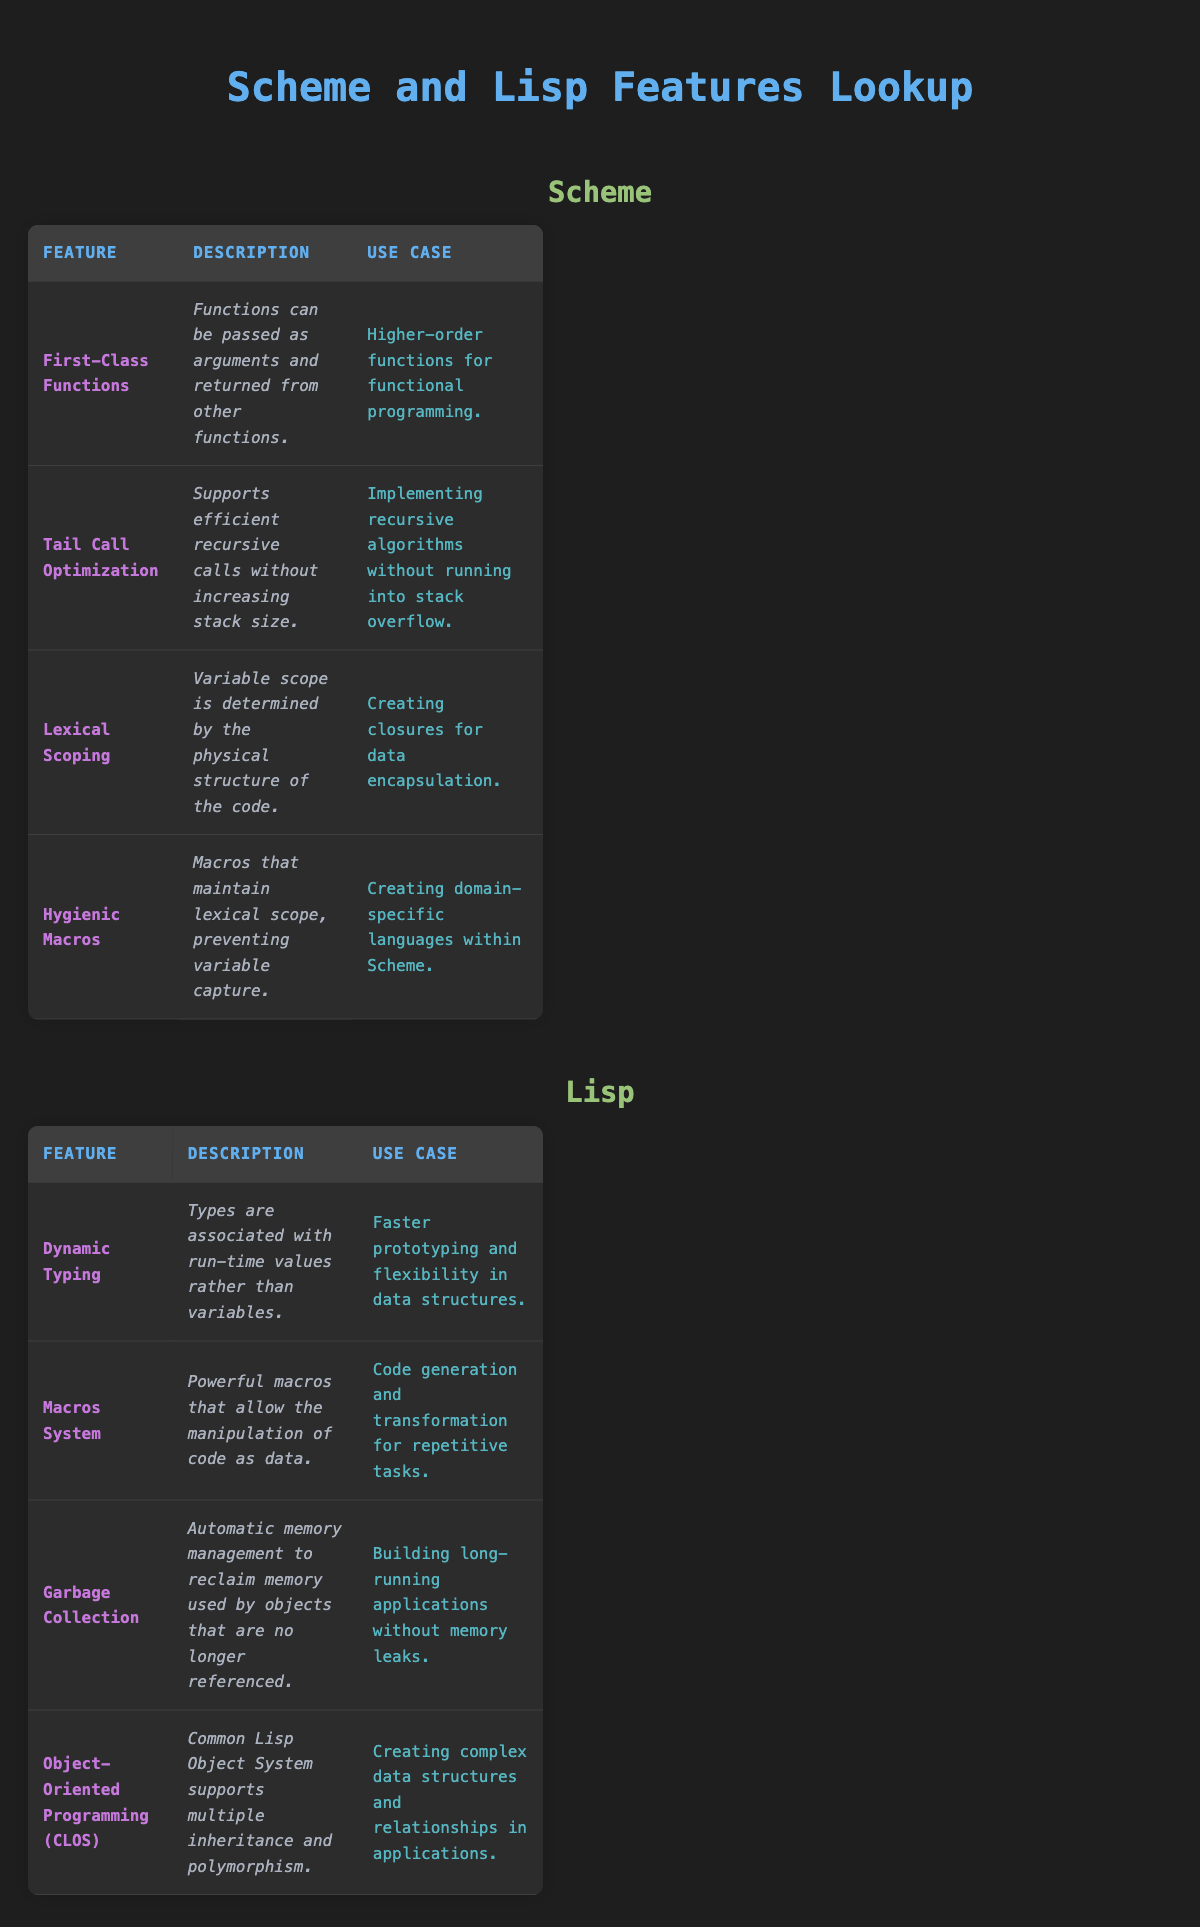What's a feature of Scheme that supports higher-order functions? According to the table, the feature that supports higher-order functions in Scheme is "First-Class Functions," which allows functions to be passed as arguments and returned from other functions.
Answer: First-Class Functions What is the use case for Tail Call Optimization in Scheme? The table states that the use case for Tail Call Optimization is "Implementing recursive algorithms without running into stack overflow," which shows its significance in handling recursion efficiently.
Answer: Implementing recursive algorithms without running into stack overflow Does Lisp support dynamic typing? From the information in the table under Lisp's features, it is indicated that "Types are associated with run-time values rather than variables," confirming that dynamic typing is indeed a feature of Lisp.
Answer: Yes How many features listed under Lisp involve code manipulation? The table identifies the "Macros System" as a feature of Lisp that allows the manipulation of code as data, supporting code generation and transformation. This means there is one feature in Lisp specifically focused on code manipulation.
Answer: 1 Which language has hygienic macros? By looking at the table, we can see that "Hygienic Macros" is listed as a feature under Scheme, indicating that it is a feature exclusive to Scheme and not found in Lisp.
Answer: Scheme What is the total number of features listed for Scheme and Lisp combined? Summing the features gives us four for Scheme and four for Lisp. Therefore, the total number of features is 4 + 4 = 8.
Answer: 8 Is garbage collection a feature of Scheme? The table indicates that "Garbage Collection" is specifically listed as a feature of Lisp, which means it is not a feature of Scheme.
Answer: No What commonality do the "Object-Oriented Programming" feature in Lisp and "Lexical Scoping" feature in Scheme share? Both features are essential to their respective languages for enhancing code structure; Lexical Scoping relates to variable management in Scheme while Object-Oriented Programming helps in modeling complex data structures in Lisp, but they focus on different aspects of programming paradigms. Since the question asks for a direct shared characteristic, we can conclude they both support structured programming concepts in their unique ways.
Answer: They both support structured programming concepts 